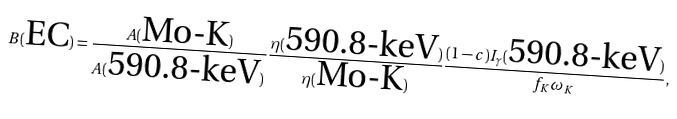Convert formula to latex. <formula><loc_0><loc_0><loc_500><loc_500>B ( \text {EC} ) = \frac { A ( \text {Mo-K} ) } { A ( \text {590.8-keV} ) } \frac { \eta ( \text {590.8-keV} ) } { \eta ( \text {Mo-K} ) } \frac { ( 1 - c ) I _ { \gamma } ( \text {590.8-keV} ) } { f _ { K } \omega _ { K } } ,</formula> 